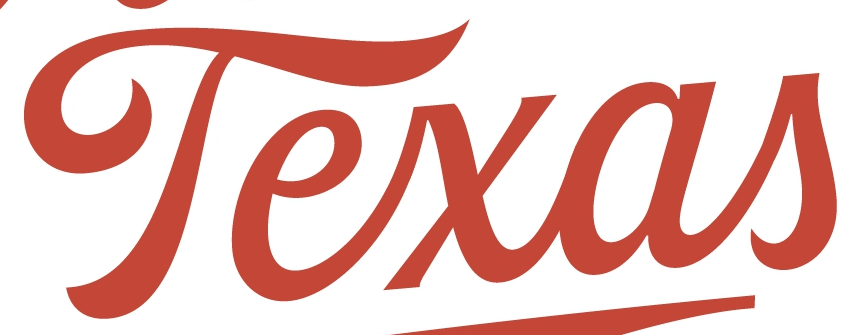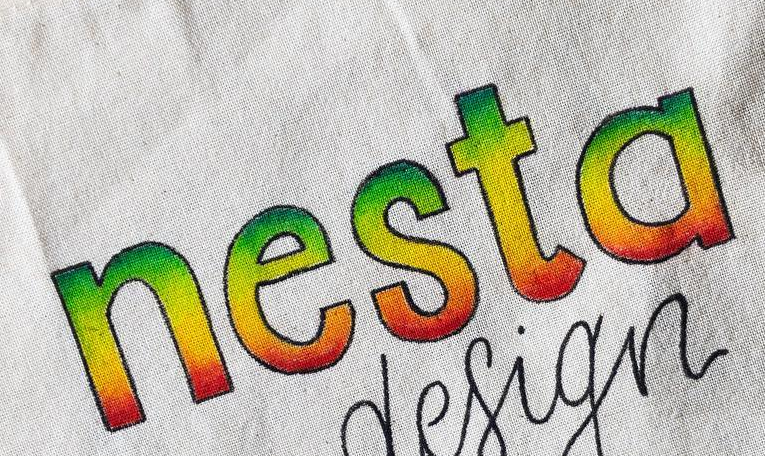What words can you see in these images in sequence, separated by a semicolon? Texas; nesta 